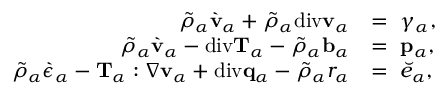<formula> <loc_0><loc_0><loc_500><loc_500>\begin{array} { r l } { \tilde { \rho } _ { \alpha } \grave { v } _ { \alpha } + \tilde { \rho } _ { \alpha } d i v v _ { \alpha } } & { = \gamma _ { \alpha } , } \\ { \tilde { \rho } _ { \alpha } \grave { v } _ { \alpha } - d i v T _ { \alpha } - \tilde { \rho } _ { \alpha } b _ { \alpha } } & { = p _ { \alpha } , } \\ { \tilde { \rho } _ { \alpha } \grave { \epsilon } _ { \alpha } - T _ { \alpha } \colon \nabla v _ { \alpha } + d i v q _ { \alpha } - \tilde { \rho } _ { \alpha } r _ { \alpha } } & { = \breve { e } _ { \alpha } , } \end{array}</formula> 